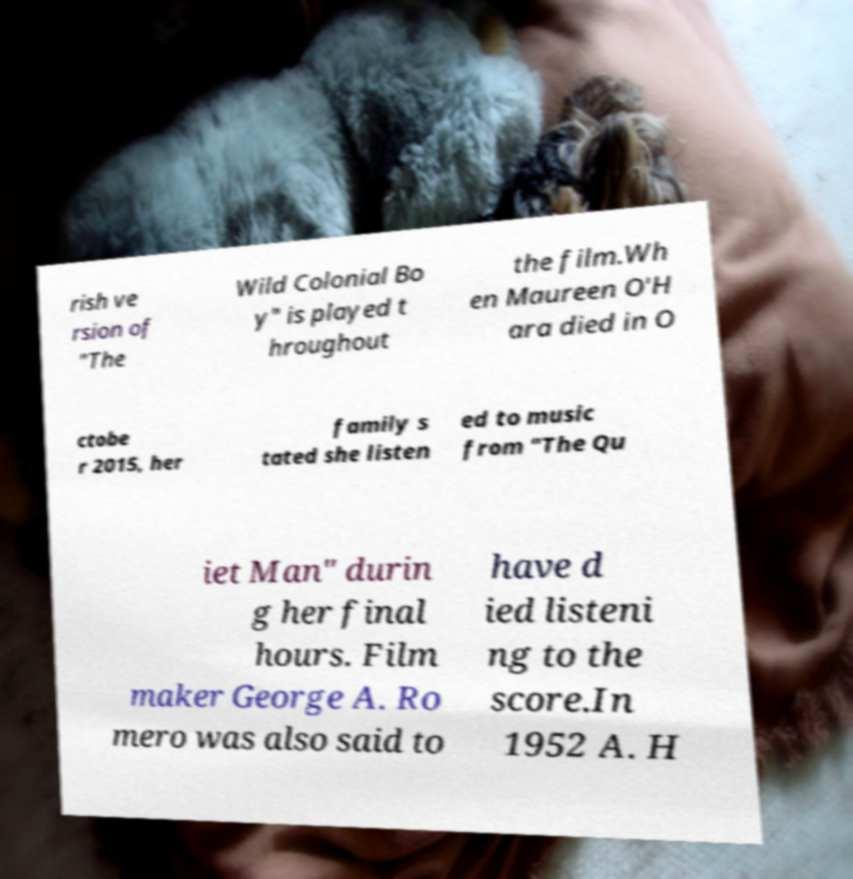I need the written content from this picture converted into text. Can you do that? rish ve rsion of "The Wild Colonial Bo y" is played t hroughout the film.Wh en Maureen O'H ara died in O ctobe r 2015, her family s tated she listen ed to music from "The Qu iet Man" durin g her final hours. Film maker George A. Ro mero was also said to have d ied listeni ng to the score.In 1952 A. H 